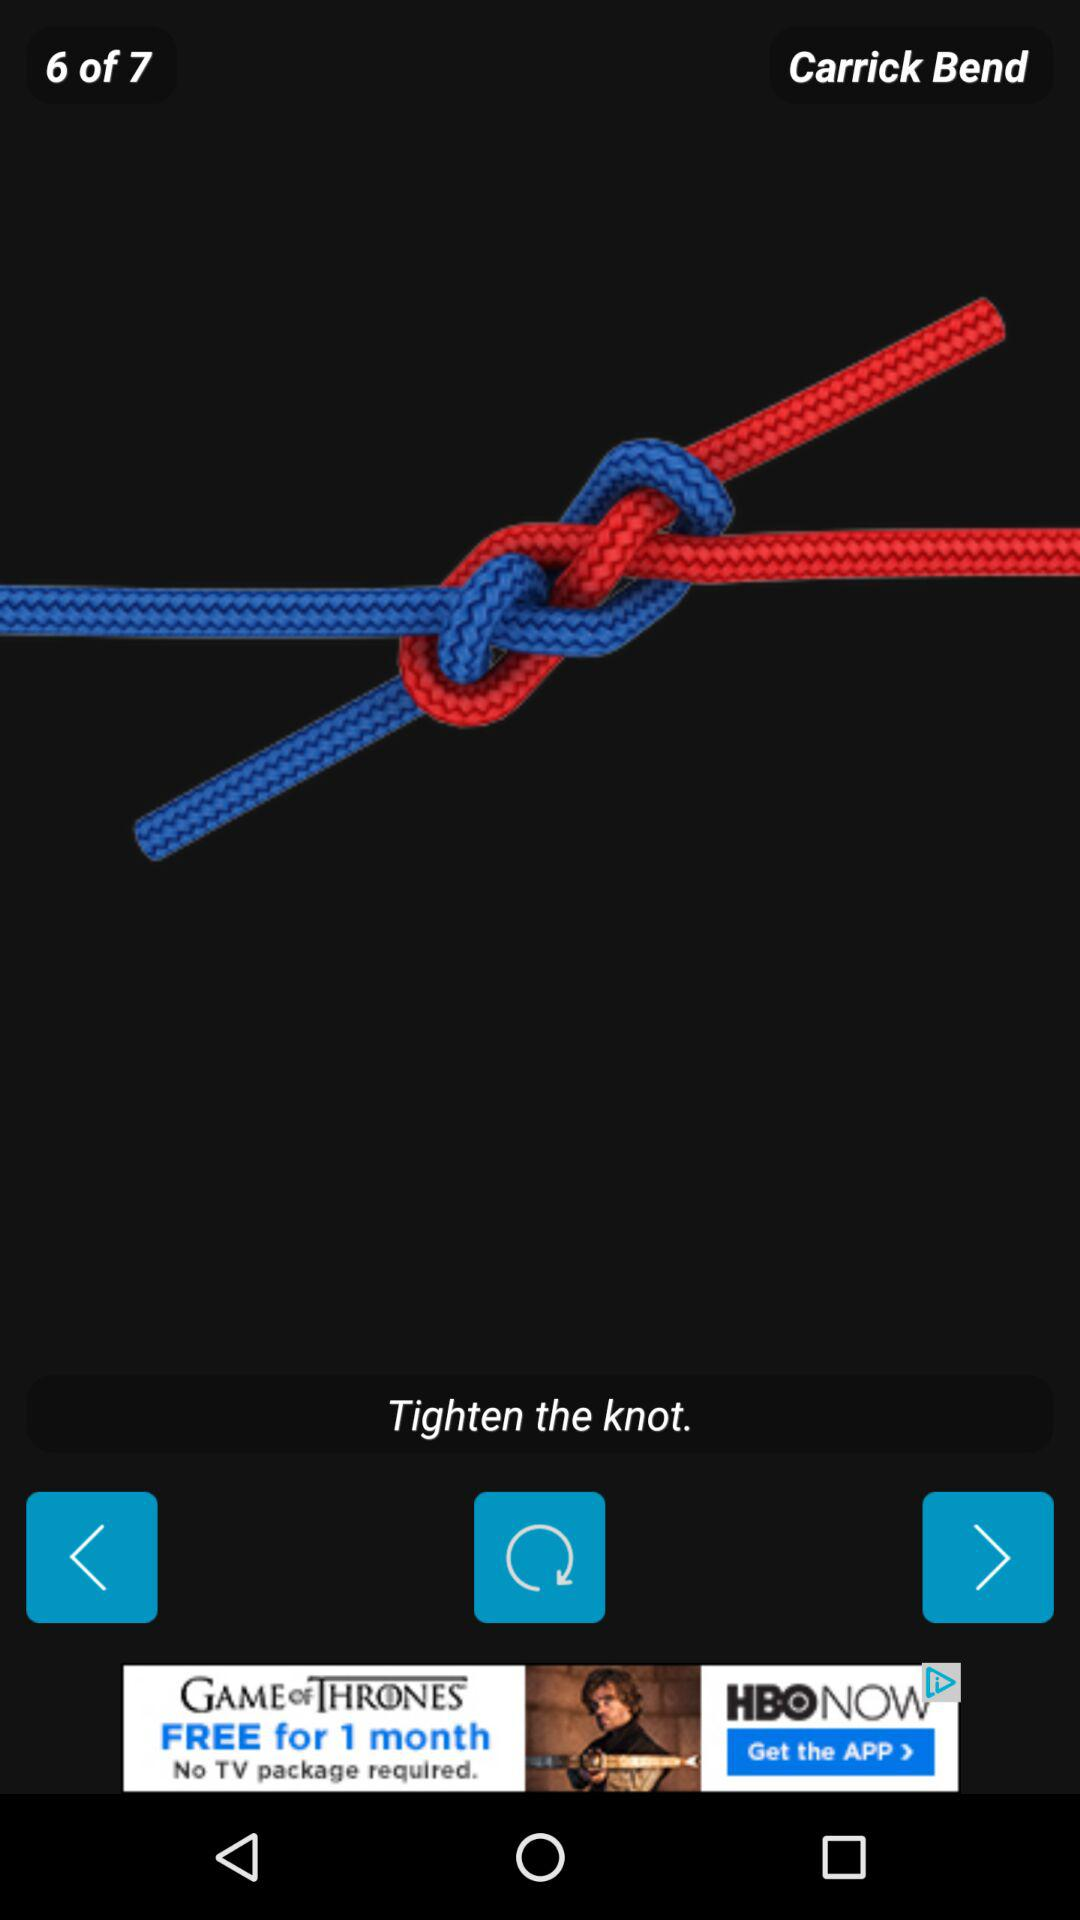How many more steps are there to complete this tutorial?
Answer the question using a single word or phrase. 1 